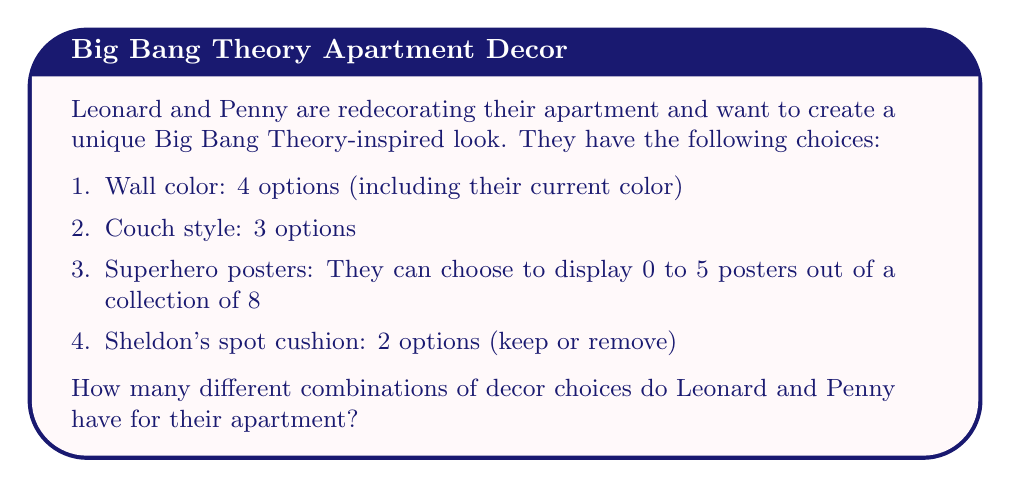Can you solve this math problem? Let's break this down step by step:

1. Wall color: There are 4 options. This is straightforward.

2. Couch style: There are 3 options. Also straightforward.

3. Superhero posters: This is where it gets interesting. They can choose anywhere from 0 to 5 posters out of 8. This is a combination problem. We need to sum up the combinations for each possible number of posters:

   $$\sum_{k=0}^5 \binom{8}{k}$$

   Let's calculate each term:
   $$\binom{8}{0} = 1$$
   $$\binom{8}{1} = 8$$
   $$\binom{8}{2} = 28$$
   $$\binom{8}{3} = 56$$
   $$\binom{8}{4} = 70$$
   $$\binom{8}{5} = 56$$

   Sum: $1 + 8 + 28 + 56 + 70 + 56 = 219$

4. Sheldon's spot cushion: 2 options (keep or remove)

Now, we use the multiplication principle to find the total number of combinations:

$$4 \times 3 \times 219 \times 2 = 5,256$$

Therefore, Leonard and Penny have 5,256 different combinations for their apartment decor.
Answer: 5,256 combinations 